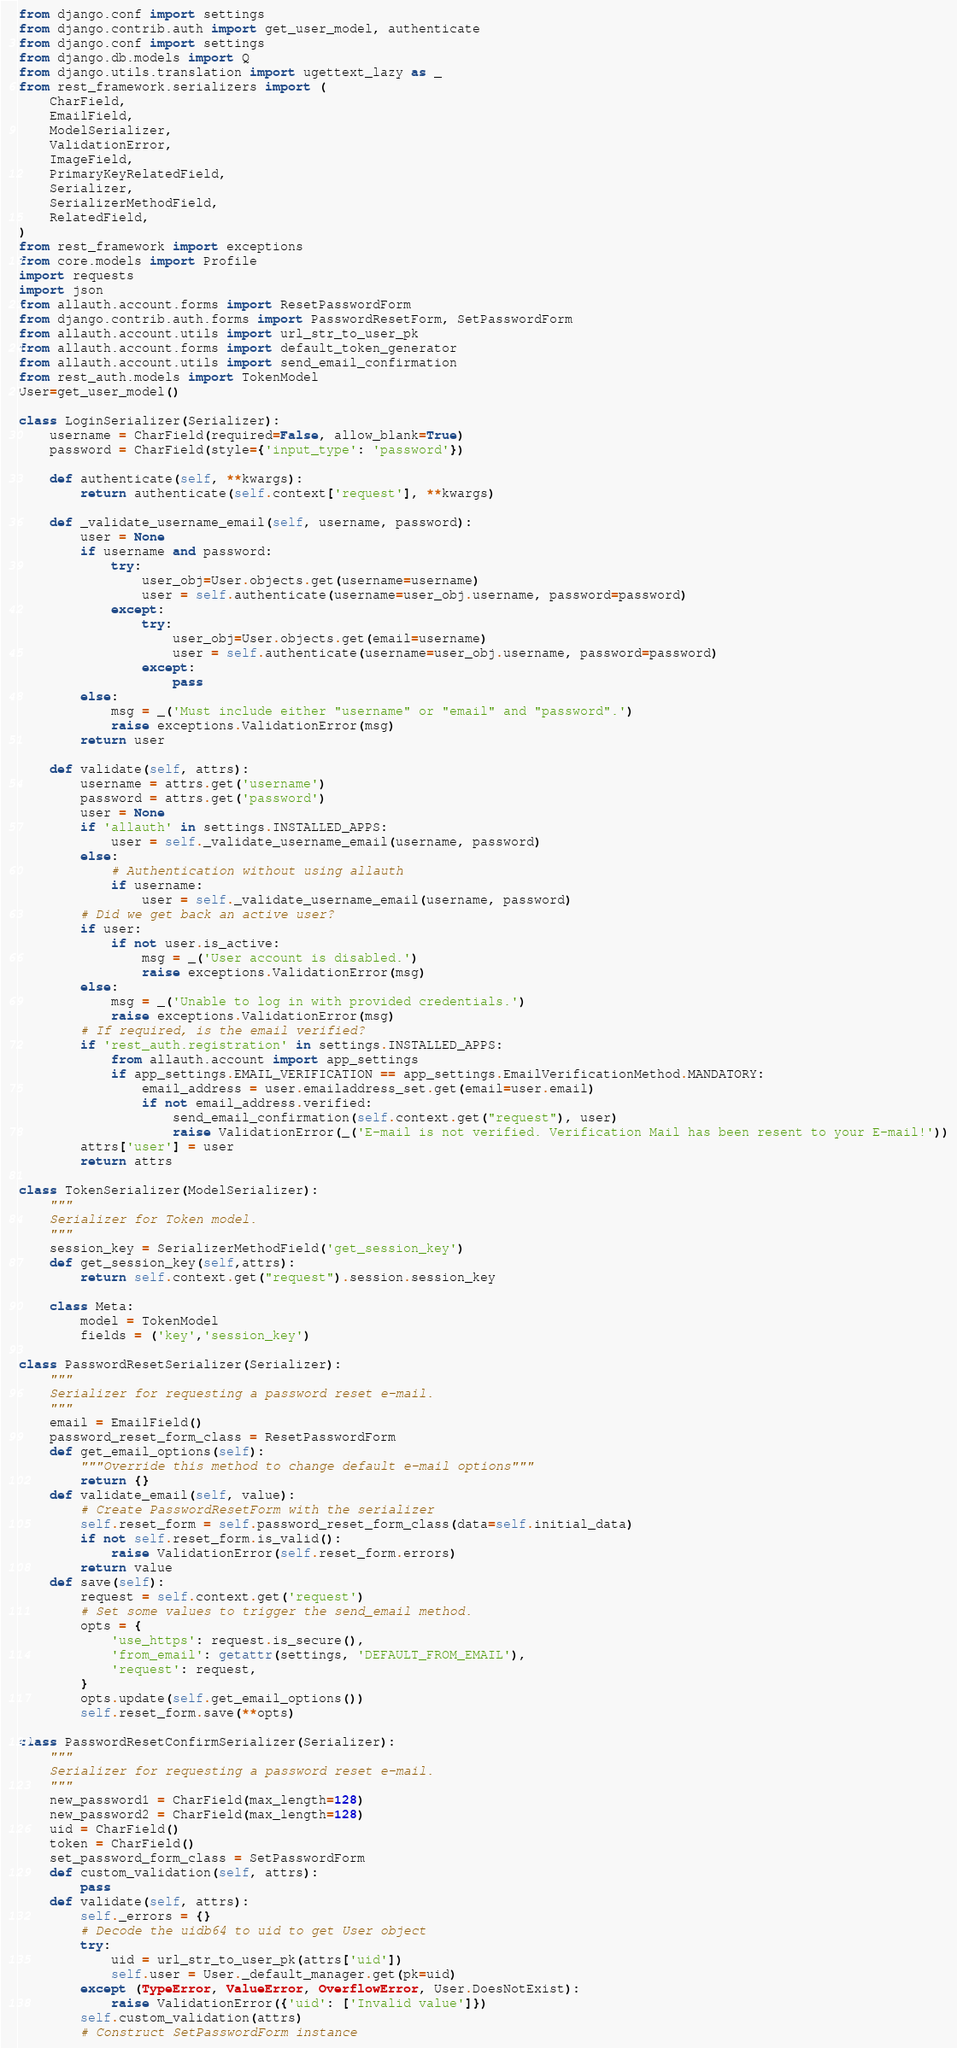<code> <loc_0><loc_0><loc_500><loc_500><_Python_>from django.conf import settings
from django.contrib.auth import get_user_model, authenticate
from django.conf import settings
from django.db.models import Q
from django.utils.translation import ugettext_lazy as _
from rest_framework.serializers import ( 
    CharField,
    EmailField,
    ModelSerializer,
    ValidationError,
    ImageField,
    PrimaryKeyRelatedField,
    Serializer,
    SerializerMethodField,
    RelatedField,
)
from rest_framework import exceptions
from core.models import Profile
import requests
import json
from allauth.account.forms import ResetPasswordForm
from django.contrib.auth.forms import PasswordResetForm, SetPasswordForm
from allauth.account.utils import url_str_to_user_pk
from allauth.account.forms import default_token_generator
from allauth.account.utils import send_email_confirmation
from rest_auth.models import TokenModel
User=get_user_model()

class LoginSerializer(Serializer):
    username = CharField(required=False, allow_blank=True)
    password = CharField(style={'input_type': 'password'})

    def authenticate(self, **kwargs):
        return authenticate(self.context['request'], **kwargs)

    def _validate_username_email(self, username, password):
        user = None
        if username and password:
            try:
                user_obj=User.objects.get(username=username)
                user = self.authenticate(username=user_obj.username, password=password)
            except:
                try:
                    user_obj=User.objects.get(email=username)
                    user = self.authenticate(username=user_obj.username, password=password)
                except:
                    pass
        else:
            msg = _('Must include either "username" or "email" and "password".')
            raise exceptions.ValidationError(msg)
        return user

    def validate(self, attrs):
        username = attrs.get('username')
        password = attrs.get('password')
        user = None
        if 'allauth' in settings.INSTALLED_APPS:
            user = self._validate_username_email(username, password)
        else:
            # Authentication without using allauth
            if username:
                user = self._validate_username_email(username, password)
        # Did we get back an active user?
        if user:
            if not user.is_active:
                msg = _('User account is disabled.')
                raise exceptions.ValidationError(msg)
        else:
            msg = _('Unable to log in with provided credentials.')
            raise exceptions.ValidationError(msg)
        # If required, is the email verified?
        if 'rest_auth.registration' in settings.INSTALLED_APPS:
            from allauth.account import app_settings
            if app_settings.EMAIL_VERIFICATION == app_settings.EmailVerificationMethod.MANDATORY:
                email_address = user.emailaddress_set.get(email=user.email)
                if not email_address.verified:
                    send_email_confirmation(self.context.get("request"), user)
                    raise ValidationError(_('E-mail is not verified. Verification Mail has been resent to your E-mail!'))
        attrs['user'] = user
        return attrs

class TokenSerializer(ModelSerializer):
    """
    Serializer for Token model.
    """
    session_key = SerializerMethodField('get_session_key')
    def get_session_key(self,attrs):
        return self.context.get("request").session.session_key

    class Meta:
        model = TokenModel
        fields = ('key','session_key')

class PasswordResetSerializer(Serializer):
    """
    Serializer for requesting a password reset e-mail.
    """
    email = EmailField()
    password_reset_form_class = ResetPasswordForm
    def get_email_options(self):
        """Override this method to change default e-mail options"""
        return {}
    def validate_email(self, value):
        # Create PasswordResetForm with the serializer
        self.reset_form = self.password_reset_form_class(data=self.initial_data)
        if not self.reset_form.is_valid():
            raise ValidationError(self.reset_form.errors)
        return value
    def save(self):
        request = self.context.get('request')
        # Set some values to trigger the send_email method.
        opts = {
            'use_https': request.is_secure(),
            'from_email': getattr(settings, 'DEFAULT_FROM_EMAIL'),
            'request': request,
        }
        opts.update(self.get_email_options())
        self.reset_form.save(**opts)

class PasswordResetConfirmSerializer(Serializer):
    """
    Serializer for requesting a password reset e-mail.
    """
    new_password1 = CharField(max_length=128)
    new_password2 = CharField(max_length=128)
    uid = CharField()
    token = CharField()
    set_password_form_class = SetPasswordForm
    def custom_validation(self, attrs):
        pass
    def validate(self, attrs):
        self._errors = {}
        # Decode the uidb64 to uid to get User object
        try:
            uid = url_str_to_user_pk(attrs['uid'])
            self.user = User._default_manager.get(pk=uid)
        except (TypeError, ValueError, OverflowError, User.DoesNotExist):
            raise ValidationError({'uid': ['Invalid value']})
        self.custom_validation(attrs)
        # Construct SetPasswordForm instance</code> 